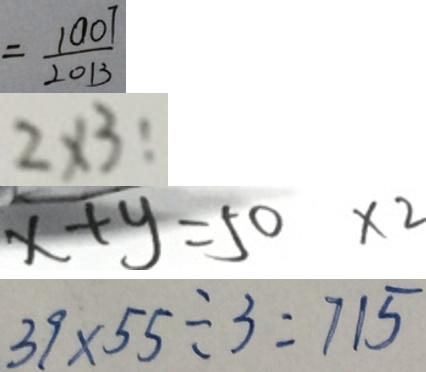Convert formula to latex. <formula><loc_0><loc_0><loc_500><loc_500>= \frac { 1 0 0 7 } { 2 0 1 3 } 
 2 \times 3 : 
 x + y = 5 0 \times 2 
 3 9 \times 5 5 \div 3 = 7 1 5</formula> 